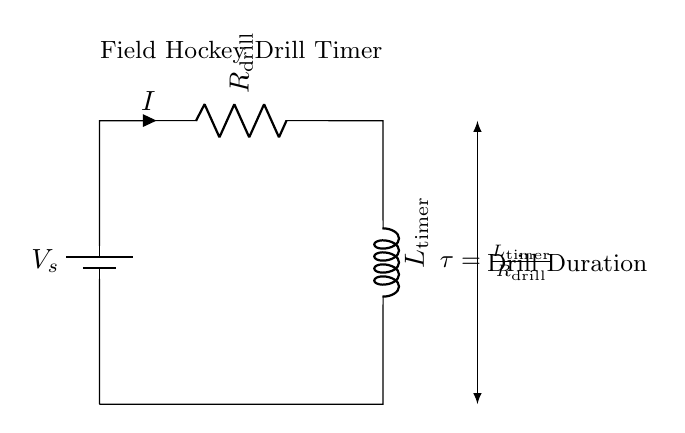What does the battery represent? The battery represents the power source for the RL circuit, providing a voltage of V_s.
Answer: voltage V_s What are the two main components in this RL circuit? The two main components are the resistor and the inductor, labeled as R_drill and L_timer.
Answer: resistor and inductor How is the current labeled in this circuit? The current is labeled as I, which flows through the resistor R_drill.
Answer: I What is the formula for the time constant in this circuit? The time constant, τ, is provided in the circuit as τ = L_timer / R_drill, indicating how quickly the current can change relative to the resistance and inductance.
Answer: τ = L_timer / R_drill What does an increase in the resistance (R_drill) do to the time constant (τ)? Increasing the resistance increases the time constant τ, which leads to a slower response in the circuit for any changes in the circuit condition, delaying the timer's completion.
Answer: increases τ If L_timer is doubled, what happens to τ? If L_timer is doubled, the time constant τ will also double, indicating that the circuit takes longer to respond to changes since τ is directly proportional to L_timer.
Answer: τ doubles What represents the drill duration in relation to the timer? The arrow near the inductor shows the direction and implies that the drill duration directly relates to the time constant τ's value, indicating how long the timer will keep running.
Answer: Drill Duration 